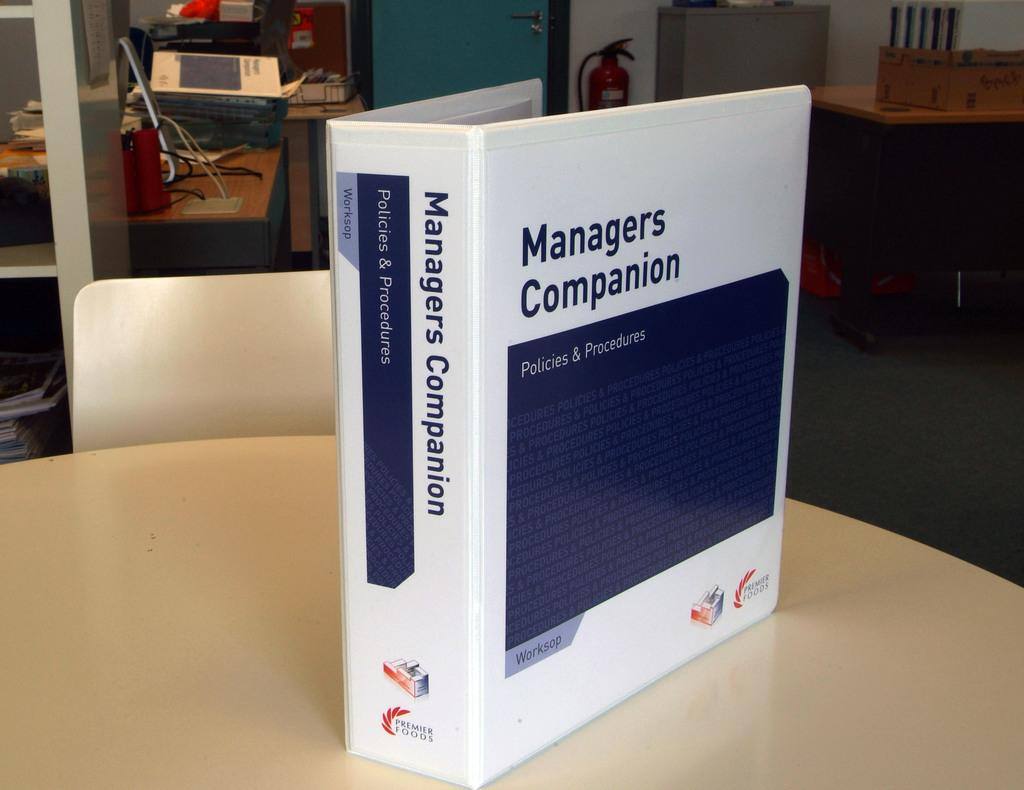What is on the table in the image? There is a book on a table in the image. What is located behind the table? There is a chair behind the table in the image. What is behind the chair? There is a door behind the chair in the image. What safety equipment is present in the image? Fire extinguishers are present in the image. What type of paperwork is visible in the image? There are files in the image. Are there any other objects visible in the image? Yes, there are other objects visible in the image. Can you tell me how many jelly beans are on the chair in the image? There are no jelly beans present in the image; the chair is behind the table. Is there a man sitting on the table in the image? There is no man present in the image; the only person mentioned is the chair behind the table. 